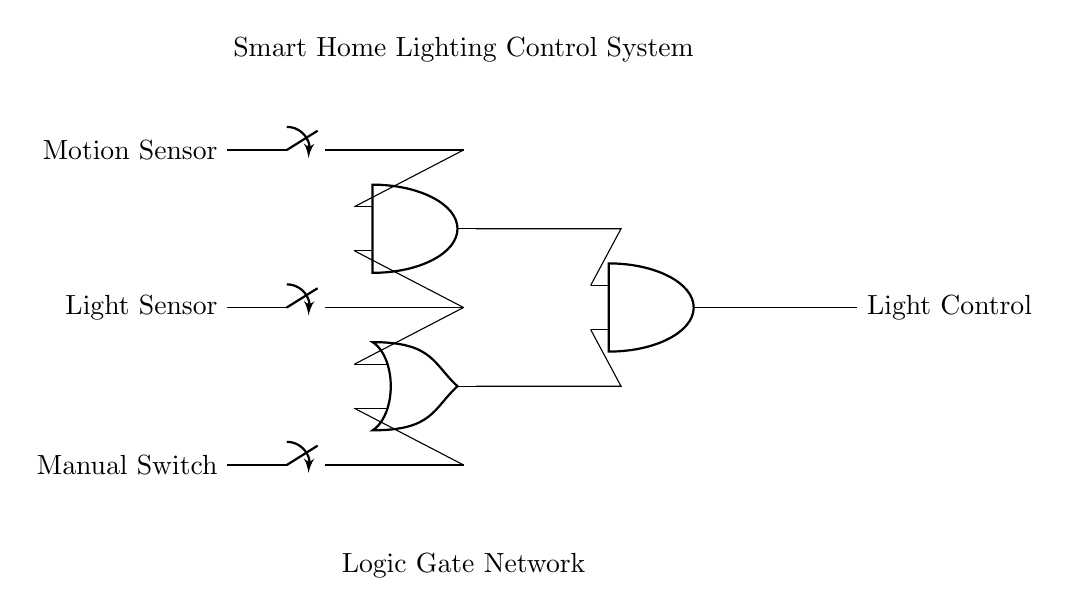What inputs are used in this circuit? The circuit uses three inputs: Motion Sensor, Light Sensor, and Manual Switch, as indicated by the labeled switches on the left side.
Answer: Motion Sensor, Light Sensor, Manual Switch How many logic gates are present in the diagram? The diagram contains three logic gates: two AND gates and one OR gate, which can be counted from the symbols in the circuit.
Answer: Three What is the function of the AND gate in this circuit? The AND gate takes two inputs (the Motion Sensor and Light Sensor) and outputs a signal only when both inputs are active, indicating that both conditions must be met for the light to potentially be controlled.
Answer: To combine signals Under what condition will the OR gate output a signal? The OR gate will output a signal if either of its inputs (from the Manual Switch and the AND gate) is active, meaning only one must be true for the output to be high.
Answer: If either input is active What happens when both the Motion Sensor and Light Sensor are not activated? If neither the Motion Sensor nor the Light Sensor is activated, the AND gate outputs no signal, which means the OR gate will rely solely on the Manual Switch for any output.
Answer: No output from the AND gate Which component directly controls the final output to Light Control? The final output to Light Control is controlled by the second AND gate, which takes inputs from the output of the first AND gate and the OR gate.
Answer: Second AND gate 